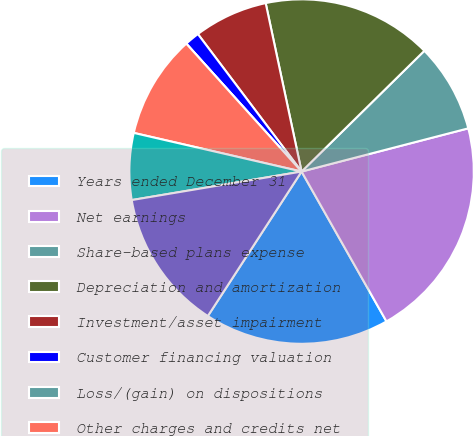Convert chart to OTSL. <chart><loc_0><loc_0><loc_500><loc_500><pie_chart><fcel>Years ended December 31<fcel>Net earnings<fcel>Share-based plans expense<fcel>Depreciation and amortization<fcel>Investment/asset impairment<fcel>Customer financing valuation<fcel>Loss/(gain) on dispositions<fcel>Other charges and credits net<fcel>Excess tax benefits from<fcel>Accounts receivable<nl><fcel>17.36%<fcel>20.83%<fcel>8.33%<fcel>15.97%<fcel>6.94%<fcel>1.39%<fcel>0.0%<fcel>9.72%<fcel>6.25%<fcel>13.19%<nl></chart> 